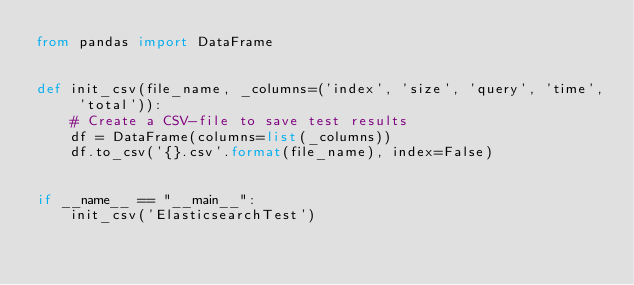Convert code to text. <code><loc_0><loc_0><loc_500><loc_500><_Python_>from pandas import DataFrame


def init_csv(file_name, _columns=('index', 'size', 'query', 'time', 'total')):
    # Create a CSV-file to save test results
    df = DataFrame(columns=list(_columns))
    df.to_csv('{}.csv'.format(file_name), index=False)


if __name__ == "__main__":
    init_csv('ElasticsearchTest')
</code> 